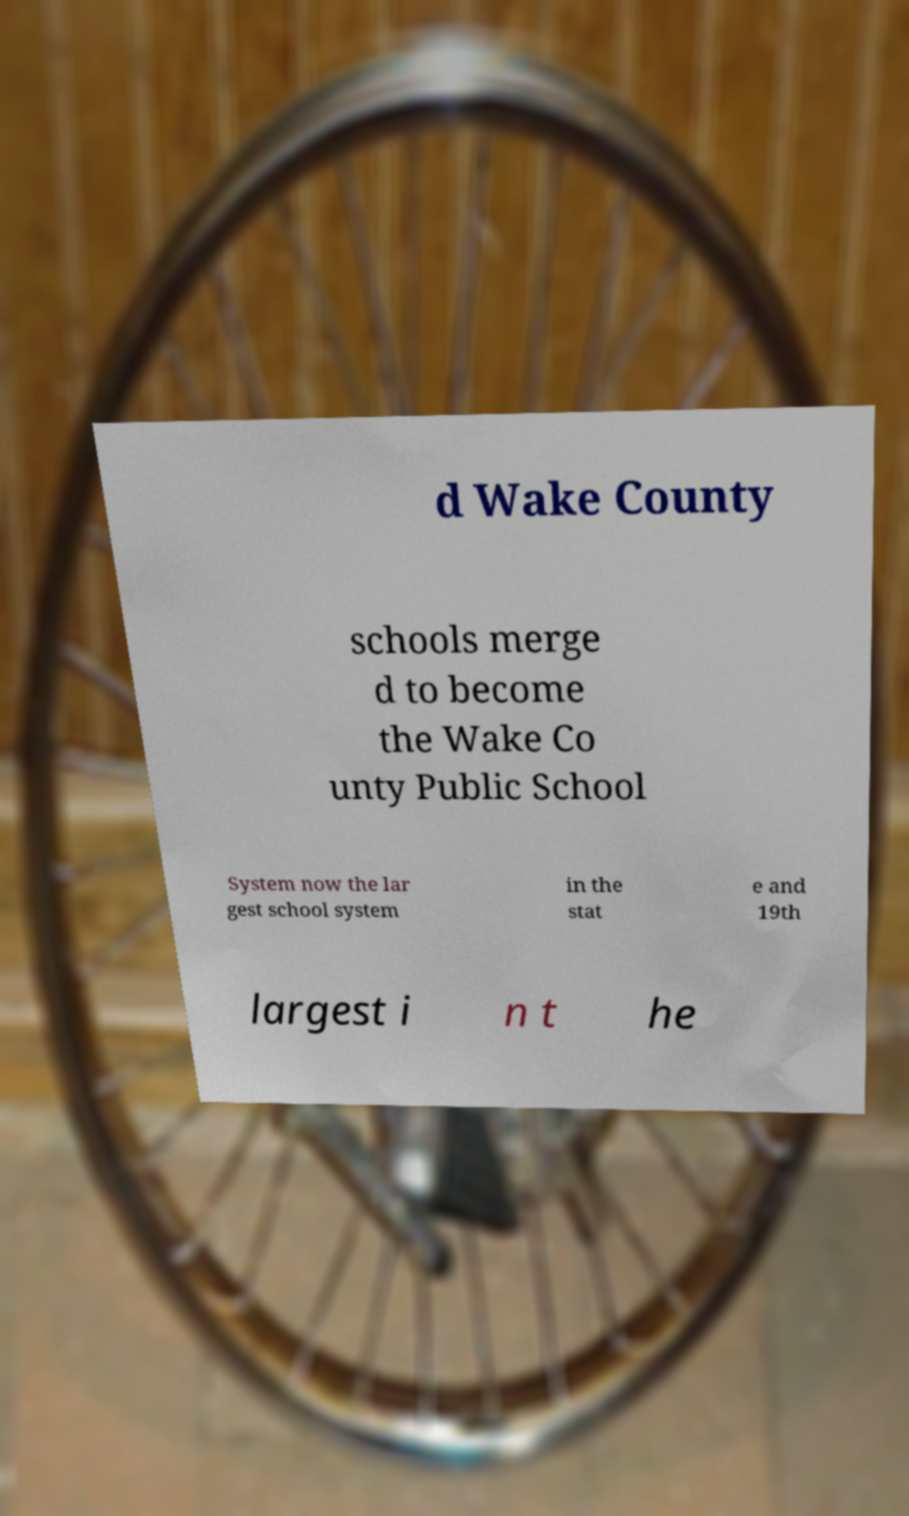What messages or text are displayed in this image? I need them in a readable, typed format. d Wake County schools merge d to become the Wake Co unty Public School System now the lar gest school system in the stat e and 19th largest i n t he 